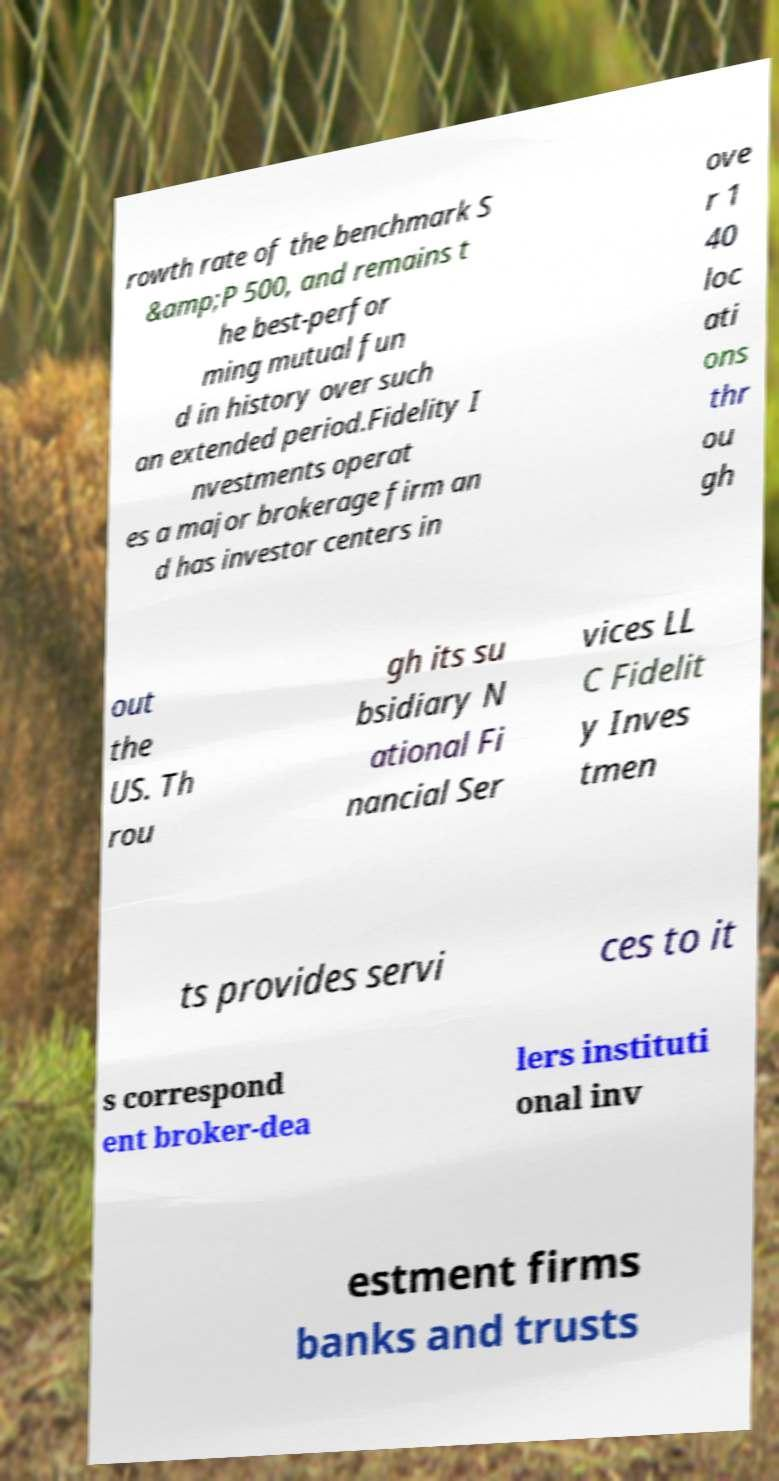For documentation purposes, I need the text within this image transcribed. Could you provide that? rowth rate of the benchmark S &amp;P 500, and remains t he best-perfor ming mutual fun d in history over such an extended period.Fidelity I nvestments operat es a major brokerage firm an d has investor centers in ove r 1 40 loc ati ons thr ou gh out the US. Th rou gh its su bsidiary N ational Fi nancial Ser vices LL C Fidelit y Inves tmen ts provides servi ces to it s correspond ent broker-dea lers instituti onal inv estment firms banks and trusts 